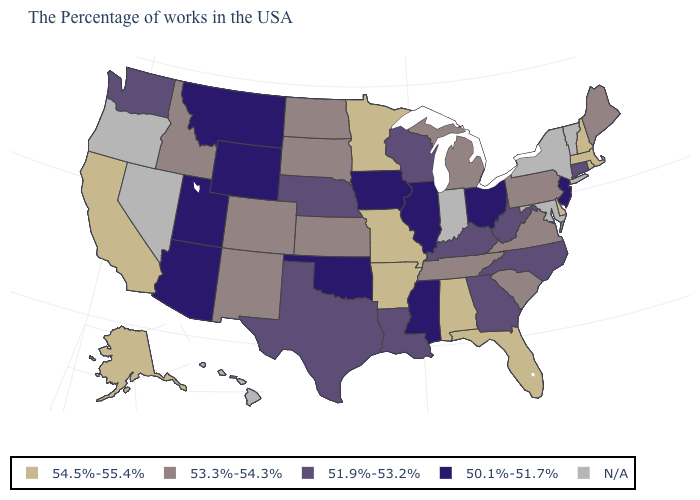What is the highest value in the MidWest ?
Write a very short answer. 54.5%-55.4%. What is the value of Virginia?
Write a very short answer. 53.3%-54.3%. What is the value of Delaware?
Quick response, please. 54.5%-55.4%. Is the legend a continuous bar?
Write a very short answer. No. Among the states that border Utah , does Idaho have the highest value?
Write a very short answer. Yes. Name the states that have a value in the range 54.5%-55.4%?
Give a very brief answer. Massachusetts, Rhode Island, New Hampshire, Delaware, Florida, Alabama, Missouri, Arkansas, Minnesota, California, Alaska. Does Rhode Island have the highest value in the USA?
Quick response, please. Yes. What is the value of North Carolina?
Short answer required. 51.9%-53.2%. Does Massachusetts have the highest value in the Northeast?
Be succinct. Yes. Among the states that border Mississippi , which have the lowest value?
Answer briefly. Louisiana. Name the states that have a value in the range 54.5%-55.4%?
Short answer required. Massachusetts, Rhode Island, New Hampshire, Delaware, Florida, Alabama, Missouri, Arkansas, Minnesota, California, Alaska. What is the value of Missouri?
Answer briefly. 54.5%-55.4%. Which states have the lowest value in the USA?
Short answer required. New Jersey, Ohio, Illinois, Mississippi, Iowa, Oklahoma, Wyoming, Utah, Montana, Arizona. Which states have the highest value in the USA?
Short answer required. Massachusetts, Rhode Island, New Hampshire, Delaware, Florida, Alabama, Missouri, Arkansas, Minnesota, California, Alaska. 